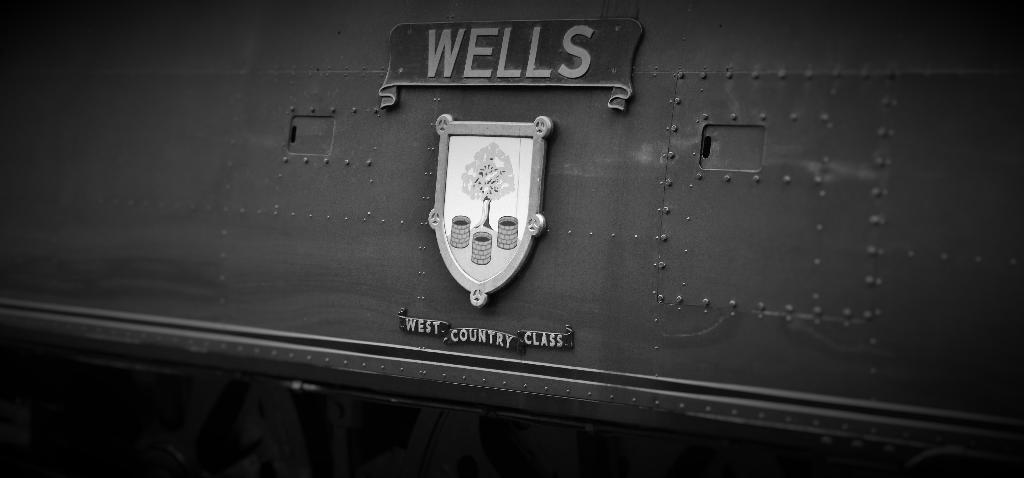What is the main object in the image that resembles a board? There is an object in the image that resembles a board. What can be seen on the board? There is text on the board. What is placed on the board? There is an object on the board. What can be observed in the drawing on the object? The drawing on the object includes trees and barrels. What type of silverware is depicted in the drawing on the object? There is no silverware mentioned or depicted in the drawing on the object; it includes trees and barrels. 